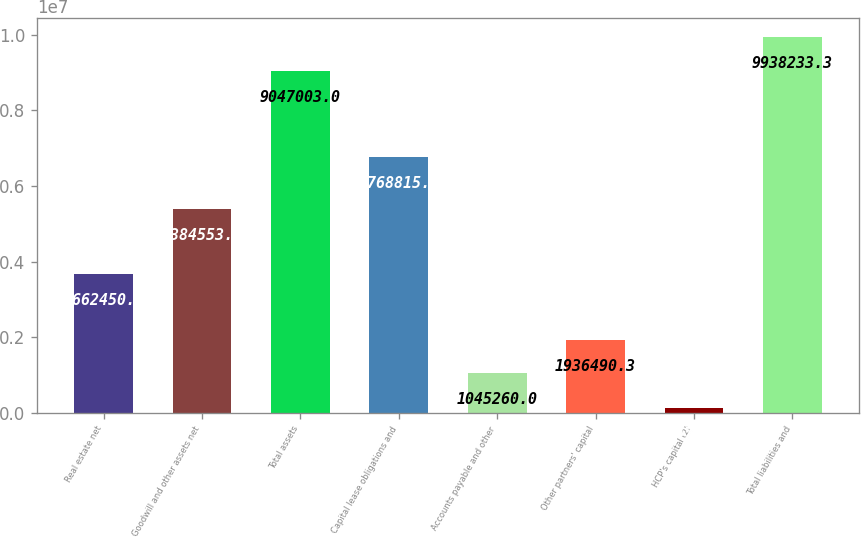Convert chart to OTSL. <chart><loc_0><loc_0><loc_500><loc_500><bar_chart><fcel>Real estate net<fcel>Goodwill and other assets net<fcel>Total assets<fcel>Capital lease obligations and<fcel>Accounts payable and other<fcel>Other partners' capital<fcel>HCP's capital (2)<fcel>Total liabilities and<nl><fcel>3.66245e+06<fcel>5.38455e+06<fcel>9.047e+06<fcel>6.76882e+06<fcel>1.04526e+06<fcel>1.93649e+06<fcel>134700<fcel>9.93823e+06<nl></chart> 